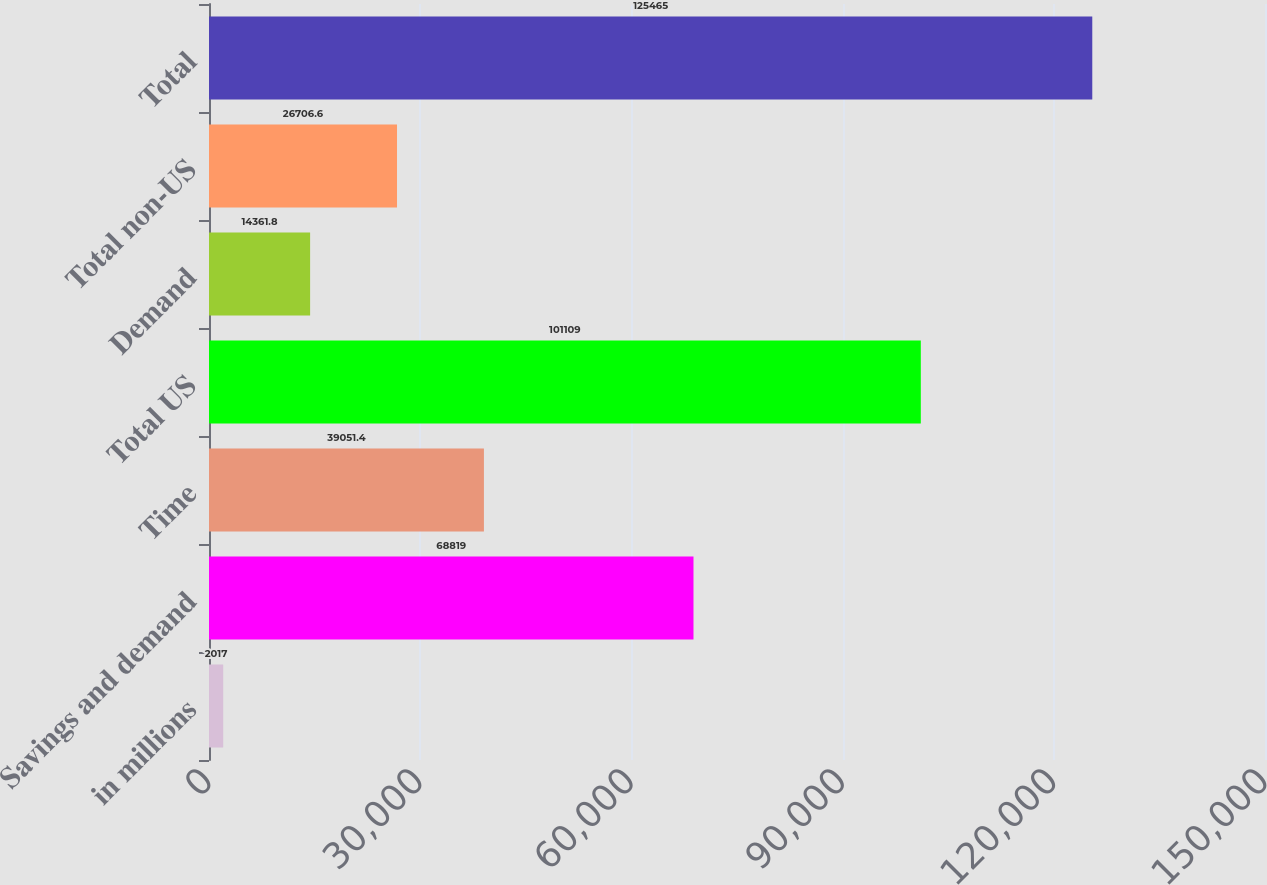<chart> <loc_0><loc_0><loc_500><loc_500><bar_chart><fcel>in millions<fcel>Savings and demand<fcel>Time<fcel>Total US<fcel>Demand<fcel>Total non-US<fcel>Total<nl><fcel>2017<fcel>68819<fcel>39051.4<fcel>101109<fcel>14361.8<fcel>26706.6<fcel>125465<nl></chart> 